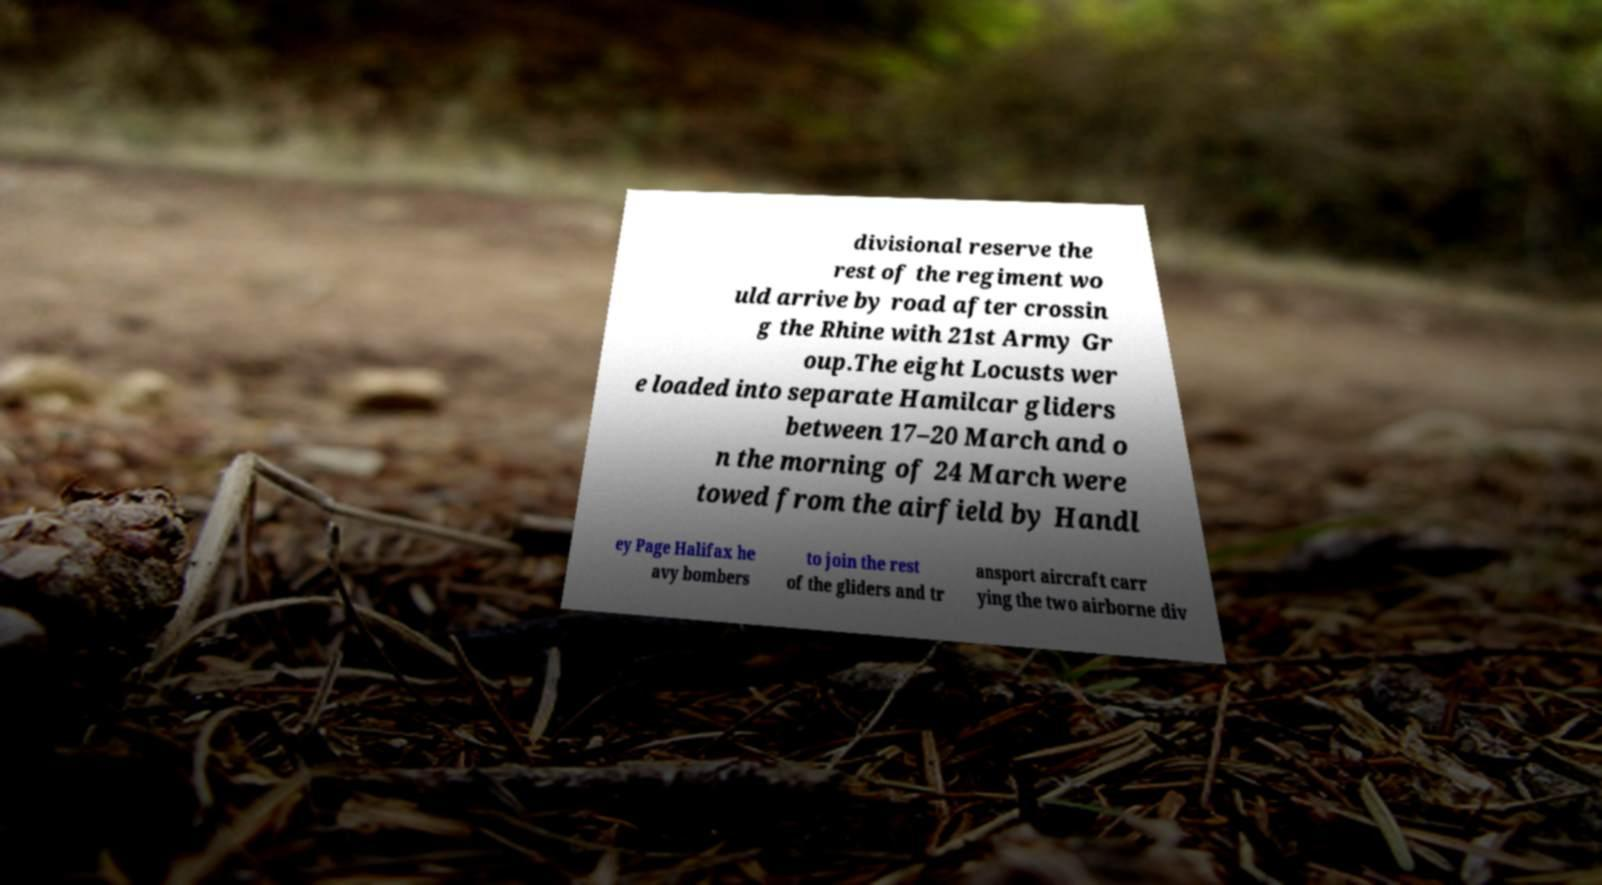Can you read and provide the text displayed in the image?This photo seems to have some interesting text. Can you extract and type it out for me? divisional reserve the rest of the regiment wo uld arrive by road after crossin g the Rhine with 21st Army Gr oup.The eight Locusts wer e loaded into separate Hamilcar gliders between 17–20 March and o n the morning of 24 March were towed from the airfield by Handl ey Page Halifax he avy bombers to join the rest of the gliders and tr ansport aircraft carr ying the two airborne div 